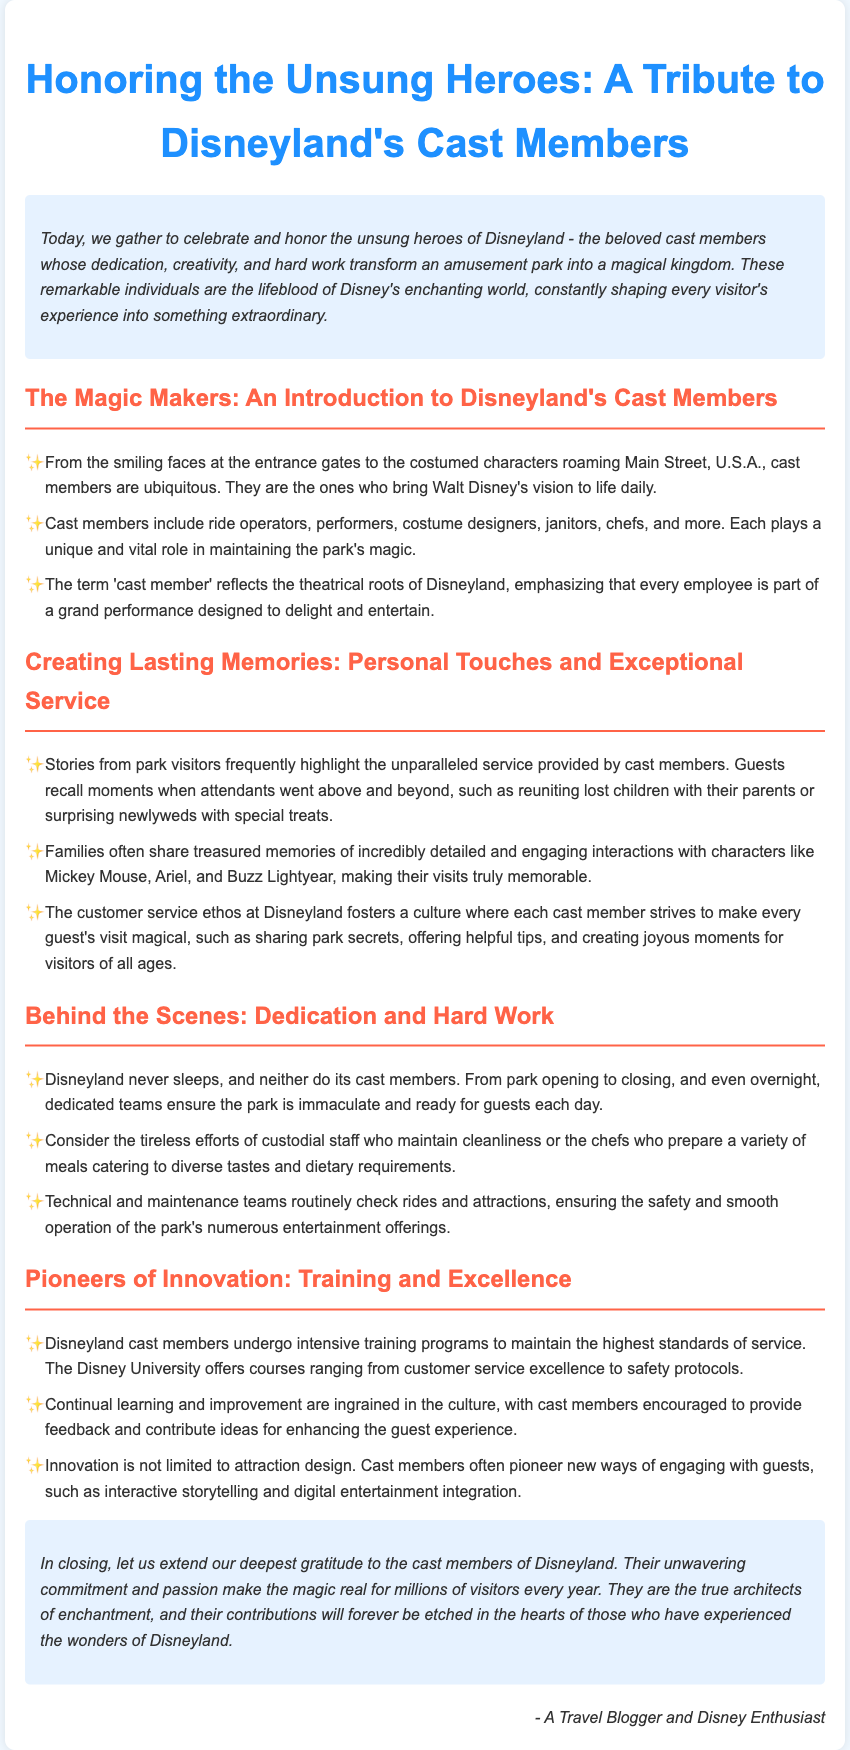What is the title of the document? The title is explicitly mentioned at the top of the document.
Answer: A Tribute to Disneyland's Cast Members Who are considered the unsung heroes of Disneyland? The document defines the primary subject of the tribute.
Answer: Cast members What role do custodian staff play according to the document? Their function is specifically highlighted in the section discussing behind-the-scenes efforts.
Answer: Maintaining cleanliness What does 'Disney University' offer? This training facility is mentioned within the Pioneers of Innovation section.
Answer: Courses Which characters are mentioned in the context of guest interactions? The document lists specific popular characters that guests interact with.
Answer: Mickey Mouse, Ariel, Buzz Lightyear What is the main purpose of the eulogy? This purpose is conveyed in the introduction and can be summarized.
Answer: Honor cast members How is the introduction styled in the document? The characteristics of the introduction can be derived from the formatting description.
Answer: Italic and background color What do cast members strive to create for guests? The document emphasizes the expectations set for cast members' interactions with guests.
Answer: Magical experiences 